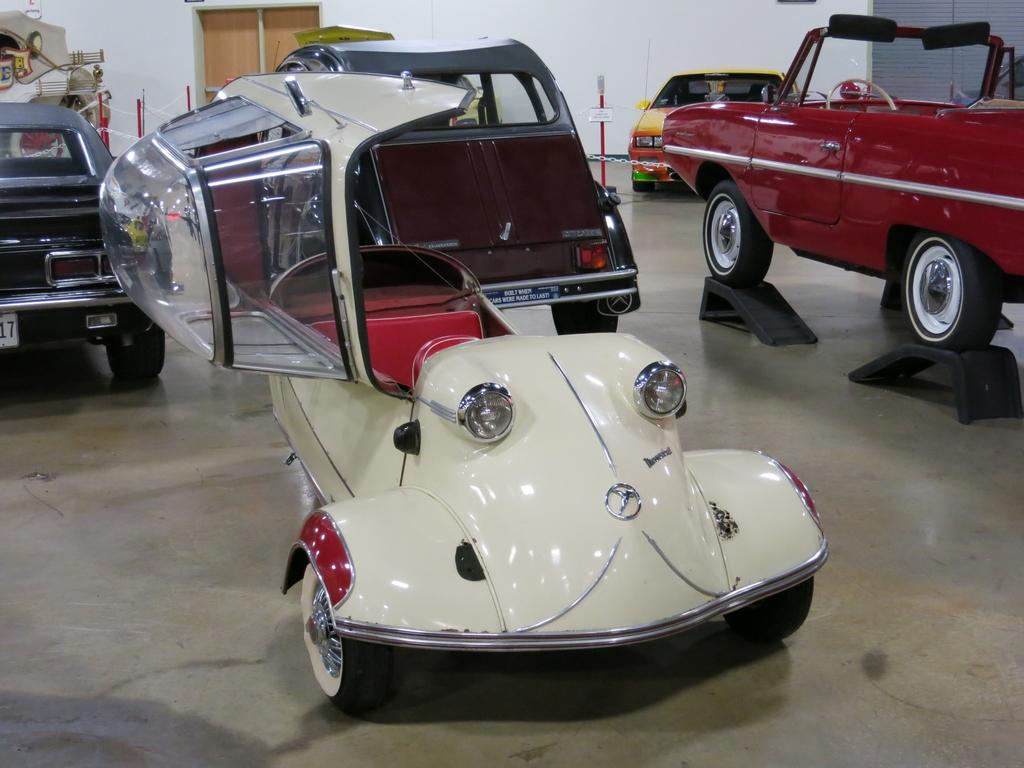What type of view is shown in the image? The image is an inside view. What objects are on the floor in the image? There are cars on the floor in the image. What can be seen in the background of the image? There is a wall and doors in the background of the image. Where is the heart-shaped balloon located in the image? There is no heart-shaped balloon present in the image. Can you see any ghosts in the image? There are no ghosts present in the image. 